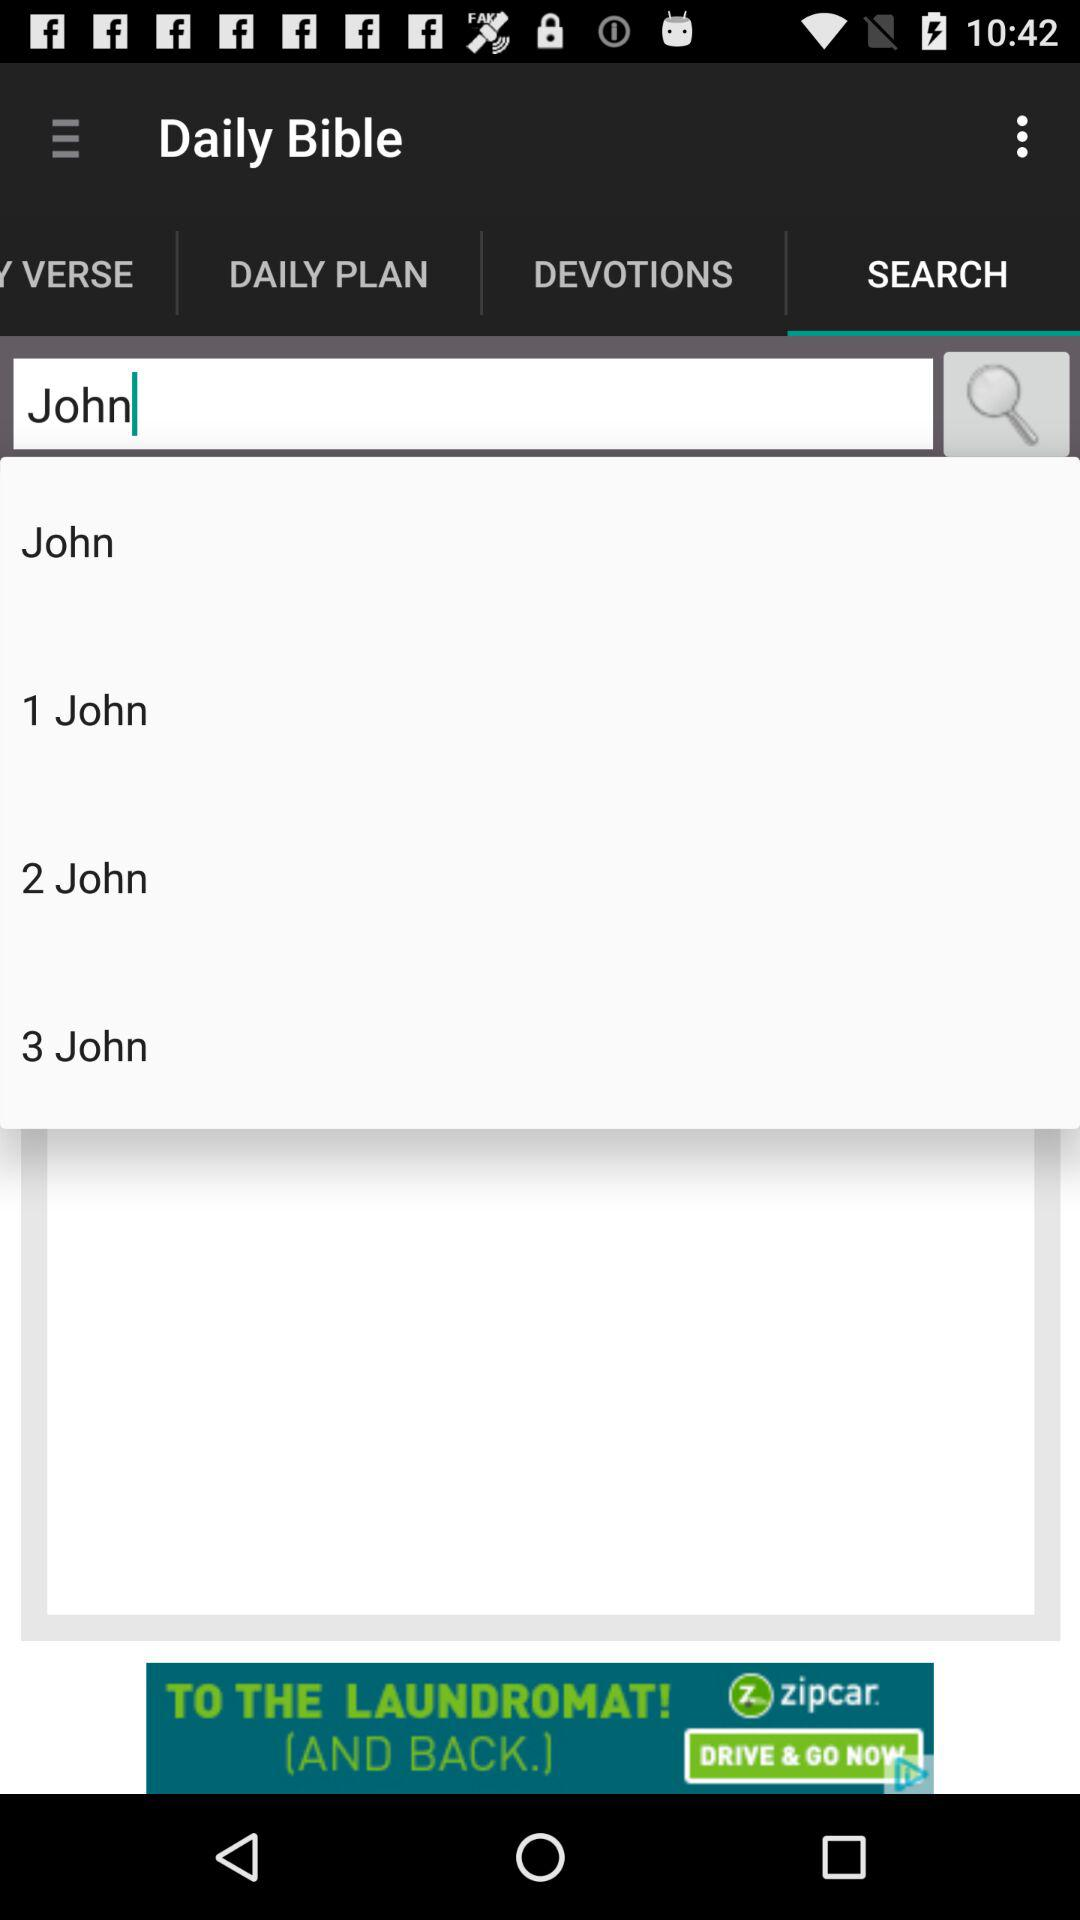Which tab is selected? The selected tab is "SEARCH". 